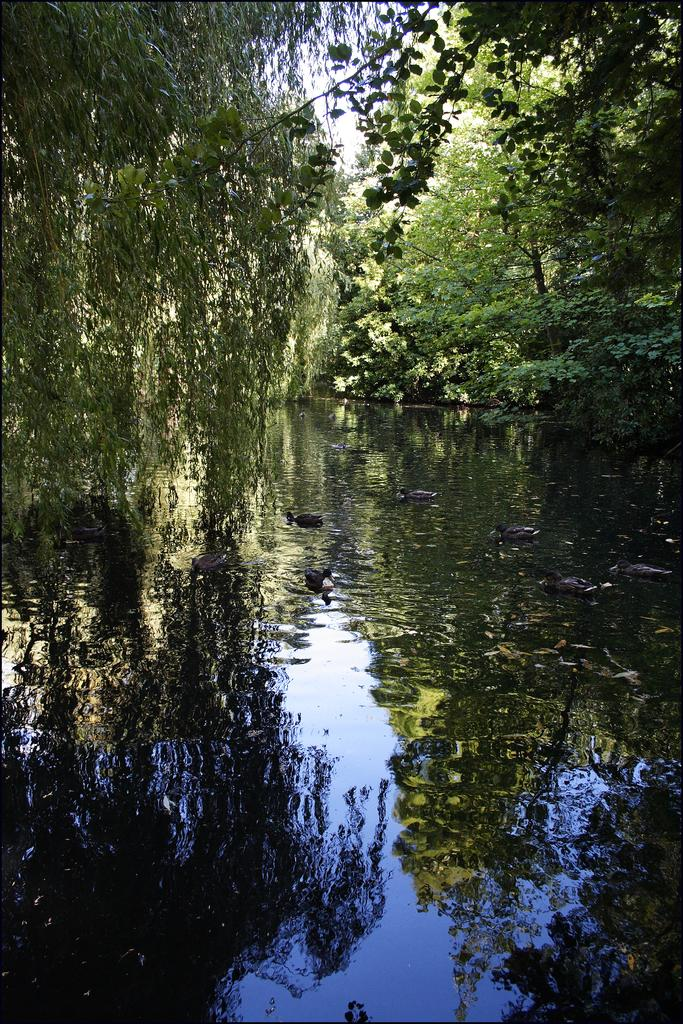What type of water feature is present in the image? There is a canal in the image. What animals can be seen in the canal? There are ducks in the canal. What can be seen in the background of the image? There are trees in the background of the image. What type of clock is visible in the image? There is no clock present in the image. What sound can be heard coming from the ducks in the image? The image is a still picture, so no sounds can be heard. 